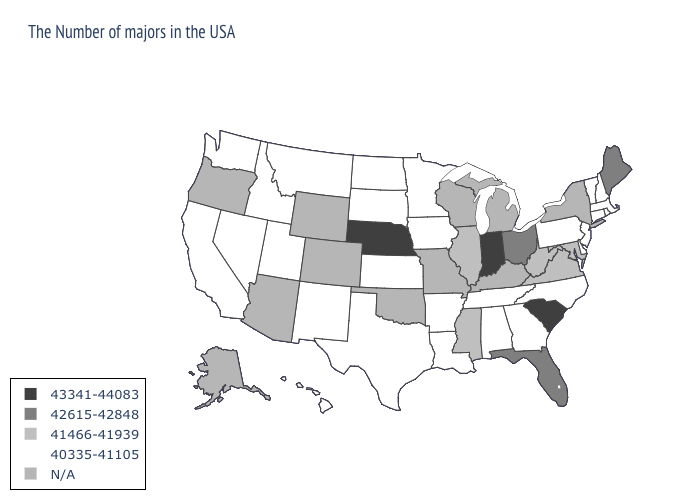Name the states that have a value in the range 42615-42848?
Give a very brief answer. Maine, Ohio, Florida. What is the value of New Hampshire?
Quick response, please. 40335-41105. What is the lowest value in the West?
Write a very short answer. 40335-41105. What is the lowest value in states that border Colorado?
Give a very brief answer. 40335-41105. What is the lowest value in the South?
Answer briefly. 40335-41105. What is the highest value in the Northeast ?
Keep it brief. 42615-42848. What is the highest value in the USA?
Short answer required. 43341-44083. Name the states that have a value in the range 43341-44083?
Quick response, please. South Carolina, Indiana, Nebraska. What is the highest value in states that border Maryland?
Give a very brief answer. 41466-41939. Name the states that have a value in the range 43341-44083?
Keep it brief. South Carolina, Indiana, Nebraska. Name the states that have a value in the range 43341-44083?
Concise answer only. South Carolina, Indiana, Nebraska. What is the lowest value in the Northeast?
Be succinct. 40335-41105. Does South Carolina have the highest value in the USA?
Short answer required. Yes. Name the states that have a value in the range 40335-41105?
Quick response, please. Massachusetts, Rhode Island, New Hampshire, Vermont, Connecticut, New Jersey, Delaware, Pennsylvania, North Carolina, Georgia, Alabama, Tennessee, Louisiana, Arkansas, Minnesota, Iowa, Kansas, Texas, South Dakota, North Dakota, New Mexico, Utah, Montana, Idaho, Nevada, California, Washington, Hawaii. What is the lowest value in states that border Tennessee?
Quick response, please. 40335-41105. 